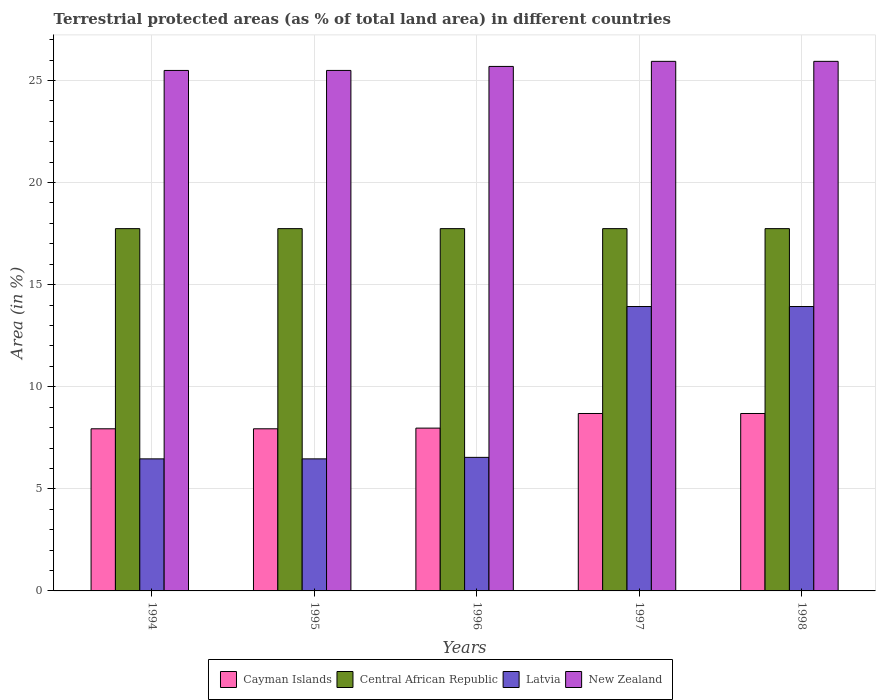How many different coloured bars are there?
Provide a short and direct response. 4. How many groups of bars are there?
Offer a terse response. 5. Are the number of bars per tick equal to the number of legend labels?
Provide a succinct answer. Yes. What is the percentage of terrestrial protected land in New Zealand in 1994?
Your answer should be compact. 25.49. Across all years, what is the maximum percentage of terrestrial protected land in New Zealand?
Keep it short and to the point. 25.94. Across all years, what is the minimum percentage of terrestrial protected land in Cayman Islands?
Keep it short and to the point. 7.94. In which year was the percentage of terrestrial protected land in Latvia maximum?
Offer a terse response. 1997. What is the total percentage of terrestrial protected land in New Zealand in the graph?
Provide a short and direct response. 128.55. What is the difference between the percentage of terrestrial protected land in Cayman Islands in 1994 and that in 1997?
Your answer should be very brief. -0.75. What is the difference between the percentage of terrestrial protected land in Central African Republic in 1997 and the percentage of terrestrial protected land in New Zealand in 1995?
Offer a terse response. -7.75. What is the average percentage of terrestrial protected land in Cayman Islands per year?
Give a very brief answer. 8.25. In the year 1997, what is the difference between the percentage of terrestrial protected land in Central African Republic and percentage of terrestrial protected land in Cayman Islands?
Offer a terse response. 9.05. What is the ratio of the percentage of terrestrial protected land in Cayman Islands in 1995 to that in 1996?
Provide a succinct answer. 1. What is the difference between the highest and the second highest percentage of terrestrial protected land in Central African Republic?
Your answer should be very brief. 3.37733425013198e-5. What is the difference between the highest and the lowest percentage of terrestrial protected land in New Zealand?
Provide a short and direct response. 0.45. In how many years, is the percentage of terrestrial protected land in Latvia greater than the average percentage of terrestrial protected land in Latvia taken over all years?
Your response must be concise. 2. Is the sum of the percentage of terrestrial protected land in Latvia in 1994 and 1995 greater than the maximum percentage of terrestrial protected land in Cayman Islands across all years?
Offer a terse response. Yes. Is it the case that in every year, the sum of the percentage of terrestrial protected land in Cayman Islands and percentage of terrestrial protected land in Latvia is greater than the sum of percentage of terrestrial protected land in Central African Republic and percentage of terrestrial protected land in New Zealand?
Make the answer very short. No. What does the 2nd bar from the left in 1994 represents?
Offer a very short reply. Central African Republic. What does the 4th bar from the right in 1995 represents?
Make the answer very short. Cayman Islands. Is it the case that in every year, the sum of the percentage of terrestrial protected land in Latvia and percentage of terrestrial protected land in New Zealand is greater than the percentage of terrestrial protected land in Cayman Islands?
Give a very brief answer. Yes. How many bars are there?
Provide a short and direct response. 20. What is the difference between two consecutive major ticks on the Y-axis?
Make the answer very short. 5. Are the values on the major ticks of Y-axis written in scientific E-notation?
Offer a terse response. No. Does the graph contain grids?
Offer a terse response. Yes. How are the legend labels stacked?
Ensure brevity in your answer.  Horizontal. What is the title of the graph?
Offer a very short reply. Terrestrial protected areas (as % of total land area) in different countries. What is the label or title of the Y-axis?
Your response must be concise. Area (in %). What is the Area (in %) in Cayman Islands in 1994?
Your response must be concise. 7.94. What is the Area (in %) of Central African Republic in 1994?
Your answer should be compact. 17.74. What is the Area (in %) of Latvia in 1994?
Offer a very short reply. 6.47. What is the Area (in %) of New Zealand in 1994?
Keep it short and to the point. 25.49. What is the Area (in %) in Cayman Islands in 1995?
Offer a very short reply. 7.94. What is the Area (in %) of Central African Republic in 1995?
Provide a succinct answer. 17.74. What is the Area (in %) of Latvia in 1995?
Your answer should be compact. 6.47. What is the Area (in %) in New Zealand in 1995?
Give a very brief answer. 25.49. What is the Area (in %) of Cayman Islands in 1996?
Ensure brevity in your answer.  7.97. What is the Area (in %) of Central African Republic in 1996?
Provide a succinct answer. 17.74. What is the Area (in %) in Latvia in 1996?
Keep it short and to the point. 6.54. What is the Area (in %) of New Zealand in 1996?
Give a very brief answer. 25.69. What is the Area (in %) in Cayman Islands in 1997?
Provide a short and direct response. 8.69. What is the Area (in %) of Central African Republic in 1997?
Provide a short and direct response. 17.74. What is the Area (in %) in Latvia in 1997?
Make the answer very short. 13.93. What is the Area (in %) of New Zealand in 1997?
Your answer should be compact. 25.94. What is the Area (in %) in Cayman Islands in 1998?
Keep it short and to the point. 8.69. What is the Area (in %) of Central African Republic in 1998?
Keep it short and to the point. 17.74. What is the Area (in %) of Latvia in 1998?
Make the answer very short. 13.93. What is the Area (in %) of New Zealand in 1998?
Make the answer very short. 25.94. Across all years, what is the maximum Area (in %) in Cayman Islands?
Make the answer very short. 8.69. Across all years, what is the maximum Area (in %) of Central African Republic?
Keep it short and to the point. 17.74. Across all years, what is the maximum Area (in %) in Latvia?
Provide a short and direct response. 13.93. Across all years, what is the maximum Area (in %) of New Zealand?
Ensure brevity in your answer.  25.94. Across all years, what is the minimum Area (in %) in Cayman Islands?
Keep it short and to the point. 7.94. Across all years, what is the minimum Area (in %) of Central African Republic?
Provide a short and direct response. 17.74. Across all years, what is the minimum Area (in %) of Latvia?
Offer a very short reply. 6.47. Across all years, what is the minimum Area (in %) in New Zealand?
Offer a very short reply. 25.49. What is the total Area (in %) in Cayman Islands in the graph?
Offer a terse response. 41.24. What is the total Area (in %) in Central African Republic in the graph?
Offer a very short reply. 88.72. What is the total Area (in %) in Latvia in the graph?
Give a very brief answer. 47.34. What is the total Area (in %) in New Zealand in the graph?
Offer a terse response. 128.55. What is the difference between the Area (in %) in Cayman Islands in 1994 and that in 1995?
Give a very brief answer. 0. What is the difference between the Area (in %) in Latvia in 1994 and that in 1995?
Provide a succinct answer. 0. What is the difference between the Area (in %) in New Zealand in 1994 and that in 1995?
Make the answer very short. -0. What is the difference between the Area (in %) in Cayman Islands in 1994 and that in 1996?
Your answer should be compact. -0.03. What is the difference between the Area (in %) of Latvia in 1994 and that in 1996?
Provide a short and direct response. -0.07. What is the difference between the Area (in %) of New Zealand in 1994 and that in 1996?
Ensure brevity in your answer.  -0.2. What is the difference between the Area (in %) in Cayman Islands in 1994 and that in 1997?
Ensure brevity in your answer.  -0.75. What is the difference between the Area (in %) of Central African Republic in 1994 and that in 1997?
Your answer should be very brief. 0. What is the difference between the Area (in %) in Latvia in 1994 and that in 1997?
Offer a very short reply. -7.46. What is the difference between the Area (in %) in New Zealand in 1994 and that in 1997?
Ensure brevity in your answer.  -0.45. What is the difference between the Area (in %) of Cayman Islands in 1994 and that in 1998?
Your answer should be compact. -0.75. What is the difference between the Area (in %) in Latvia in 1994 and that in 1998?
Provide a succinct answer. -7.46. What is the difference between the Area (in %) in New Zealand in 1994 and that in 1998?
Make the answer very short. -0.45. What is the difference between the Area (in %) of Cayman Islands in 1995 and that in 1996?
Your response must be concise. -0.03. What is the difference between the Area (in %) in Latvia in 1995 and that in 1996?
Provide a succinct answer. -0.07. What is the difference between the Area (in %) in New Zealand in 1995 and that in 1996?
Keep it short and to the point. -0.2. What is the difference between the Area (in %) of Cayman Islands in 1995 and that in 1997?
Give a very brief answer. -0.75. What is the difference between the Area (in %) of Latvia in 1995 and that in 1997?
Give a very brief answer. -7.46. What is the difference between the Area (in %) in New Zealand in 1995 and that in 1997?
Ensure brevity in your answer.  -0.44. What is the difference between the Area (in %) of Cayman Islands in 1995 and that in 1998?
Offer a terse response. -0.75. What is the difference between the Area (in %) in Latvia in 1995 and that in 1998?
Make the answer very short. -7.46. What is the difference between the Area (in %) of New Zealand in 1995 and that in 1998?
Provide a short and direct response. -0.44. What is the difference between the Area (in %) of Cayman Islands in 1996 and that in 1997?
Provide a succinct answer. -0.72. What is the difference between the Area (in %) in Central African Republic in 1996 and that in 1997?
Make the answer very short. 0. What is the difference between the Area (in %) in Latvia in 1996 and that in 1997?
Provide a short and direct response. -7.39. What is the difference between the Area (in %) of New Zealand in 1996 and that in 1997?
Make the answer very short. -0.25. What is the difference between the Area (in %) in Cayman Islands in 1996 and that in 1998?
Make the answer very short. -0.72. What is the difference between the Area (in %) in Latvia in 1996 and that in 1998?
Offer a very short reply. -7.39. What is the difference between the Area (in %) of New Zealand in 1996 and that in 1998?
Offer a terse response. -0.25. What is the difference between the Area (in %) in Cayman Islands in 1997 and that in 1998?
Keep it short and to the point. 0. What is the difference between the Area (in %) in Central African Republic in 1997 and that in 1998?
Give a very brief answer. -0. What is the difference between the Area (in %) in Latvia in 1997 and that in 1998?
Ensure brevity in your answer.  0. What is the difference between the Area (in %) in Cayman Islands in 1994 and the Area (in %) in Central African Republic in 1995?
Provide a short and direct response. -9.8. What is the difference between the Area (in %) in Cayman Islands in 1994 and the Area (in %) in Latvia in 1995?
Keep it short and to the point. 1.47. What is the difference between the Area (in %) in Cayman Islands in 1994 and the Area (in %) in New Zealand in 1995?
Provide a short and direct response. -17.55. What is the difference between the Area (in %) in Central African Republic in 1994 and the Area (in %) in Latvia in 1995?
Keep it short and to the point. 11.28. What is the difference between the Area (in %) in Central African Republic in 1994 and the Area (in %) in New Zealand in 1995?
Give a very brief answer. -7.75. What is the difference between the Area (in %) of Latvia in 1994 and the Area (in %) of New Zealand in 1995?
Your answer should be compact. -19.02. What is the difference between the Area (in %) in Cayman Islands in 1994 and the Area (in %) in Central African Republic in 1996?
Give a very brief answer. -9.8. What is the difference between the Area (in %) of Cayman Islands in 1994 and the Area (in %) of Latvia in 1996?
Ensure brevity in your answer.  1.4. What is the difference between the Area (in %) in Cayman Islands in 1994 and the Area (in %) in New Zealand in 1996?
Your answer should be very brief. -17.75. What is the difference between the Area (in %) of Central African Republic in 1994 and the Area (in %) of Latvia in 1996?
Offer a very short reply. 11.2. What is the difference between the Area (in %) of Central African Republic in 1994 and the Area (in %) of New Zealand in 1996?
Your answer should be very brief. -7.94. What is the difference between the Area (in %) in Latvia in 1994 and the Area (in %) in New Zealand in 1996?
Make the answer very short. -19.22. What is the difference between the Area (in %) of Cayman Islands in 1994 and the Area (in %) of Central African Republic in 1997?
Provide a short and direct response. -9.8. What is the difference between the Area (in %) in Cayman Islands in 1994 and the Area (in %) in Latvia in 1997?
Provide a short and direct response. -5.99. What is the difference between the Area (in %) of Cayman Islands in 1994 and the Area (in %) of New Zealand in 1997?
Offer a very short reply. -18. What is the difference between the Area (in %) of Central African Republic in 1994 and the Area (in %) of Latvia in 1997?
Provide a succinct answer. 3.82. What is the difference between the Area (in %) of Central African Republic in 1994 and the Area (in %) of New Zealand in 1997?
Make the answer very short. -8.19. What is the difference between the Area (in %) of Latvia in 1994 and the Area (in %) of New Zealand in 1997?
Your response must be concise. -19.47. What is the difference between the Area (in %) in Cayman Islands in 1994 and the Area (in %) in Central African Republic in 1998?
Offer a very short reply. -9.8. What is the difference between the Area (in %) of Cayman Islands in 1994 and the Area (in %) of Latvia in 1998?
Your response must be concise. -5.99. What is the difference between the Area (in %) of Cayman Islands in 1994 and the Area (in %) of New Zealand in 1998?
Make the answer very short. -18. What is the difference between the Area (in %) in Central African Republic in 1994 and the Area (in %) in Latvia in 1998?
Give a very brief answer. 3.82. What is the difference between the Area (in %) in Central African Republic in 1994 and the Area (in %) in New Zealand in 1998?
Offer a very short reply. -8.19. What is the difference between the Area (in %) of Latvia in 1994 and the Area (in %) of New Zealand in 1998?
Keep it short and to the point. -19.47. What is the difference between the Area (in %) in Cayman Islands in 1995 and the Area (in %) in Central African Republic in 1996?
Your response must be concise. -9.8. What is the difference between the Area (in %) of Cayman Islands in 1995 and the Area (in %) of Latvia in 1996?
Your answer should be very brief. 1.4. What is the difference between the Area (in %) of Cayman Islands in 1995 and the Area (in %) of New Zealand in 1996?
Offer a very short reply. -17.75. What is the difference between the Area (in %) in Central African Republic in 1995 and the Area (in %) in Latvia in 1996?
Your response must be concise. 11.2. What is the difference between the Area (in %) in Central African Republic in 1995 and the Area (in %) in New Zealand in 1996?
Give a very brief answer. -7.94. What is the difference between the Area (in %) of Latvia in 1995 and the Area (in %) of New Zealand in 1996?
Your answer should be compact. -19.22. What is the difference between the Area (in %) in Cayman Islands in 1995 and the Area (in %) in Central African Republic in 1997?
Your answer should be very brief. -9.8. What is the difference between the Area (in %) in Cayman Islands in 1995 and the Area (in %) in Latvia in 1997?
Your answer should be compact. -5.99. What is the difference between the Area (in %) in Cayman Islands in 1995 and the Area (in %) in New Zealand in 1997?
Make the answer very short. -18. What is the difference between the Area (in %) in Central African Republic in 1995 and the Area (in %) in Latvia in 1997?
Keep it short and to the point. 3.82. What is the difference between the Area (in %) in Central African Republic in 1995 and the Area (in %) in New Zealand in 1997?
Give a very brief answer. -8.19. What is the difference between the Area (in %) in Latvia in 1995 and the Area (in %) in New Zealand in 1997?
Give a very brief answer. -19.47. What is the difference between the Area (in %) in Cayman Islands in 1995 and the Area (in %) in Central African Republic in 1998?
Your answer should be compact. -9.8. What is the difference between the Area (in %) of Cayman Islands in 1995 and the Area (in %) of Latvia in 1998?
Provide a succinct answer. -5.99. What is the difference between the Area (in %) in Cayman Islands in 1995 and the Area (in %) in New Zealand in 1998?
Your answer should be very brief. -18. What is the difference between the Area (in %) in Central African Republic in 1995 and the Area (in %) in Latvia in 1998?
Offer a terse response. 3.82. What is the difference between the Area (in %) of Central African Republic in 1995 and the Area (in %) of New Zealand in 1998?
Make the answer very short. -8.19. What is the difference between the Area (in %) of Latvia in 1995 and the Area (in %) of New Zealand in 1998?
Ensure brevity in your answer.  -19.47. What is the difference between the Area (in %) of Cayman Islands in 1996 and the Area (in %) of Central African Republic in 1997?
Keep it short and to the point. -9.77. What is the difference between the Area (in %) of Cayman Islands in 1996 and the Area (in %) of Latvia in 1997?
Provide a succinct answer. -5.96. What is the difference between the Area (in %) in Cayman Islands in 1996 and the Area (in %) in New Zealand in 1997?
Your answer should be compact. -17.96. What is the difference between the Area (in %) of Central African Republic in 1996 and the Area (in %) of Latvia in 1997?
Provide a succinct answer. 3.82. What is the difference between the Area (in %) of Central African Republic in 1996 and the Area (in %) of New Zealand in 1997?
Offer a terse response. -8.19. What is the difference between the Area (in %) of Latvia in 1996 and the Area (in %) of New Zealand in 1997?
Make the answer very short. -19.4. What is the difference between the Area (in %) in Cayman Islands in 1996 and the Area (in %) in Central African Republic in 1998?
Offer a very short reply. -9.77. What is the difference between the Area (in %) in Cayman Islands in 1996 and the Area (in %) in Latvia in 1998?
Make the answer very short. -5.96. What is the difference between the Area (in %) in Cayman Islands in 1996 and the Area (in %) in New Zealand in 1998?
Your answer should be very brief. -17.96. What is the difference between the Area (in %) in Central African Republic in 1996 and the Area (in %) in Latvia in 1998?
Make the answer very short. 3.82. What is the difference between the Area (in %) of Central African Republic in 1996 and the Area (in %) of New Zealand in 1998?
Keep it short and to the point. -8.19. What is the difference between the Area (in %) of Latvia in 1996 and the Area (in %) of New Zealand in 1998?
Provide a succinct answer. -19.4. What is the difference between the Area (in %) in Cayman Islands in 1997 and the Area (in %) in Central African Republic in 1998?
Keep it short and to the point. -9.05. What is the difference between the Area (in %) in Cayman Islands in 1997 and the Area (in %) in Latvia in 1998?
Give a very brief answer. -5.24. What is the difference between the Area (in %) in Cayman Islands in 1997 and the Area (in %) in New Zealand in 1998?
Offer a very short reply. -17.25. What is the difference between the Area (in %) in Central African Republic in 1997 and the Area (in %) in Latvia in 1998?
Make the answer very short. 3.82. What is the difference between the Area (in %) of Central African Republic in 1997 and the Area (in %) of New Zealand in 1998?
Your answer should be compact. -8.19. What is the difference between the Area (in %) in Latvia in 1997 and the Area (in %) in New Zealand in 1998?
Your response must be concise. -12.01. What is the average Area (in %) of Cayman Islands per year?
Your answer should be compact. 8.25. What is the average Area (in %) of Central African Republic per year?
Your answer should be very brief. 17.74. What is the average Area (in %) of Latvia per year?
Ensure brevity in your answer.  9.47. What is the average Area (in %) of New Zealand per year?
Your response must be concise. 25.71. In the year 1994, what is the difference between the Area (in %) in Cayman Islands and Area (in %) in Central African Republic?
Your answer should be very brief. -9.8. In the year 1994, what is the difference between the Area (in %) of Cayman Islands and Area (in %) of Latvia?
Make the answer very short. 1.47. In the year 1994, what is the difference between the Area (in %) in Cayman Islands and Area (in %) in New Zealand?
Your answer should be compact. -17.55. In the year 1994, what is the difference between the Area (in %) in Central African Republic and Area (in %) in Latvia?
Offer a terse response. 11.28. In the year 1994, what is the difference between the Area (in %) in Central African Republic and Area (in %) in New Zealand?
Offer a terse response. -7.75. In the year 1994, what is the difference between the Area (in %) of Latvia and Area (in %) of New Zealand?
Ensure brevity in your answer.  -19.02. In the year 1995, what is the difference between the Area (in %) of Cayman Islands and Area (in %) of Central African Republic?
Keep it short and to the point. -9.8. In the year 1995, what is the difference between the Area (in %) in Cayman Islands and Area (in %) in Latvia?
Provide a succinct answer. 1.47. In the year 1995, what is the difference between the Area (in %) of Cayman Islands and Area (in %) of New Zealand?
Ensure brevity in your answer.  -17.55. In the year 1995, what is the difference between the Area (in %) in Central African Republic and Area (in %) in Latvia?
Your answer should be very brief. 11.28. In the year 1995, what is the difference between the Area (in %) in Central African Republic and Area (in %) in New Zealand?
Offer a very short reply. -7.75. In the year 1995, what is the difference between the Area (in %) of Latvia and Area (in %) of New Zealand?
Give a very brief answer. -19.02. In the year 1996, what is the difference between the Area (in %) in Cayman Islands and Area (in %) in Central African Republic?
Your answer should be very brief. -9.77. In the year 1996, what is the difference between the Area (in %) of Cayman Islands and Area (in %) of Latvia?
Offer a very short reply. 1.43. In the year 1996, what is the difference between the Area (in %) in Cayman Islands and Area (in %) in New Zealand?
Ensure brevity in your answer.  -17.71. In the year 1996, what is the difference between the Area (in %) of Central African Republic and Area (in %) of Latvia?
Your answer should be very brief. 11.2. In the year 1996, what is the difference between the Area (in %) of Central African Republic and Area (in %) of New Zealand?
Ensure brevity in your answer.  -7.94. In the year 1996, what is the difference between the Area (in %) of Latvia and Area (in %) of New Zealand?
Your answer should be compact. -19.15. In the year 1997, what is the difference between the Area (in %) of Cayman Islands and Area (in %) of Central African Republic?
Make the answer very short. -9.05. In the year 1997, what is the difference between the Area (in %) of Cayman Islands and Area (in %) of Latvia?
Provide a succinct answer. -5.24. In the year 1997, what is the difference between the Area (in %) of Cayman Islands and Area (in %) of New Zealand?
Offer a very short reply. -17.25. In the year 1997, what is the difference between the Area (in %) in Central African Republic and Area (in %) in Latvia?
Your answer should be very brief. 3.82. In the year 1997, what is the difference between the Area (in %) of Central African Republic and Area (in %) of New Zealand?
Keep it short and to the point. -8.19. In the year 1997, what is the difference between the Area (in %) of Latvia and Area (in %) of New Zealand?
Your answer should be very brief. -12.01. In the year 1998, what is the difference between the Area (in %) of Cayman Islands and Area (in %) of Central African Republic?
Offer a very short reply. -9.05. In the year 1998, what is the difference between the Area (in %) in Cayman Islands and Area (in %) in Latvia?
Ensure brevity in your answer.  -5.24. In the year 1998, what is the difference between the Area (in %) in Cayman Islands and Area (in %) in New Zealand?
Your response must be concise. -17.25. In the year 1998, what is the difference between the Area (in %) of Central African Republic and Area (in %) of Latvia?
Provide a short and direct response. 3.82. In the year 1998, what is the difference between the Area (in %) of Central African Republic and Area (in %) of New Zealand?
Give a very brief answer. -8.19. In the year 1998, what is the difference between the Area (in %) in Latvia and Area (in %) in New Zealand?
Provide a succinct answer. -12.01. What is the ratio of the Area (in %) of Cayman Islands in 1994 to that in 1995?
Give a very brief answer. 1. What is the ratio of the Area (in %) in New Zealand in 1994 to that in 1995?
Your answer should be compact. 1. What is the ratio of the Area (in %) in Cayman Islands in 1994 to that in 1996?
Make the answer very short. 1. What is the ratio of the Area (in %) of Latvia in 1994 to that in 1996?
Offer a terse response. 0.99. What is the ratio of the Area (in %) of New Zealand in 1994 to that in 1996?
Make the answer very short. 0.99. What is the ratio of the Area (in %) in Cayman Islands in 1994 to that in 1997?
Provide a succinct answer. 0.91. What is the ratio of the Area (in %) of Central African Republic in 1994 to that in 1997?
Your response must be concise. 1. What is the ratio of the Area (in %) in Latvia in 1994 to that in 1997?
Your response must be concise. 0.46. What is the ratio of the Area (in %) in New Zealand in 1994 to that in 1997?
Offer a terse response. 0.98. What is the ratio of the Area (in %) of Cayman Islands in 1994 to that in 1998?
Your answer should be very brief. 0.91. What is the ratio of the Area (in %) in Latvia in 1994 to that in 1998?
Offer a terse response. 0.46. What is the ratio of the Area (in %) in New Zealand in 1994 to that in 1998?
Your answer should be very brief. 0.98. What is the ratio of the Area (in %) in Central African Republic in 1995 to that in 1996?
Your answer should be compact. 1. What is the ratio of the Area (in %) of New Zealand in 1995 to that in 1996?
Give a very brief answer. 0.99. What is the ratio of the Area (in %) of Cayman Islands in 1995 to that in 1997?
Make the answer very short. 0.91. What is the ratio of the Area (in %) of Latvia in 1995 to that in 1997?
Provide a succinct answer. 0.46. What is the ratio of the Area (in %) in New Zealand in 1995 to that in 1997?
Keep it short and to the point. 0.98. What is the ratio of the Area (in %) of Cayman Islands in 1995 to that in 1998?
Your answer should be very brief. 0.91. What is the ratio of the Area (in %) in Central African Republic in 1995 to that in 1998?
Ensure brevity in your answer.  1. What is the ratio of the Area (in %) in Latvia in 1995 to that in 1998?
Your answer should be compact. 0.46. What is the ratio of the Area (in %) in New Zealand in 1995 to that in 1998?
Provide a short and direct response. 0.98. What is the ratio of the Area (in %) in Cayman Islands in 1996 to that in 1997?
Keep it short and to the point. 0.92. What is the ratio of the Area (in %) in Latvia in 1996 to that in 1997?
Offer a very short reply. 0.47. What is the ratio of the Area (in %) in Cayman Islands in 1996 to that in 1998?
Provide a short and direct response. 0.92. What is the ratio of the Area (in %) in Latvia in 1996 to that in 1998?
Your answer should be compact. 0.47. What is the ratio of the Area (in %) in New Zealand in 1996 to that in 1998?
Make the answer very short. 0.99. What is the ratio of the Area (in %) of Central African Republic in 1997 to that in 1998?
Offer a very short reply. 1. What is the ratio of the Area (in %) in Latvia in 1997 to that in 1998?
Offer a very short reply. 1. What is the difference between the highest and the second highest Area (in %) in Cayman Islands?
Provide a succinct answer. 0. What is the difference between the highest and the second highest Area (in %) in Central African Republic?
Your answer should be very brief. 0. What is the difference between the highest and the lowest Area (in %) of Cayman Islands?
Make the answer very short. 0.75. What is the difference between the highest and the lowest Area (in %) of Central African Republic?
Provide a short and direct response. 0. What is the difference between the highest and the lowest Area (in %) of Latvia?
Provide a succinct answer. 7.46. What is the difference between the highest and the lowest Area (in %) in New Zealand?
Offer a terse response. 0.45. 